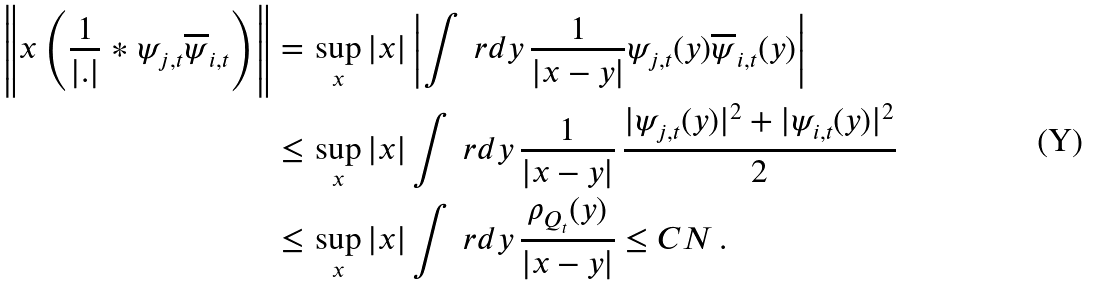<formula> <loc_0><loc_0><loc_500><loc_500>\left \| x \left ( \frac { 1 } { | . | } * \psi _ { j , t } \overline { \psi } _ { i , t } \right ) \right \| = \, & \sup _ { x } | x | \left | \int \ r d y \, \frac { 1 } { | x - y | } \psi _ { j , t } ( y ) \overline { \psi } _ { i , t } ( y ) \right | \\ \leq \, & \sup _ { x } | x | \int \ r d y \, \frac { 1 } { | x - y | } \, \frac { | \psi _ { j , t } ( y ) | ^ { 2 } + | \psi _ { i , t } ( y ) | ^ { 2 } } { 2 } \\ \leq \, & \sup _ { x } | x | \int \ r d y \, \frac { \rho _ { Q _ { t } } ( y ) } { | x - y | } \leq C N \, .</formula> 